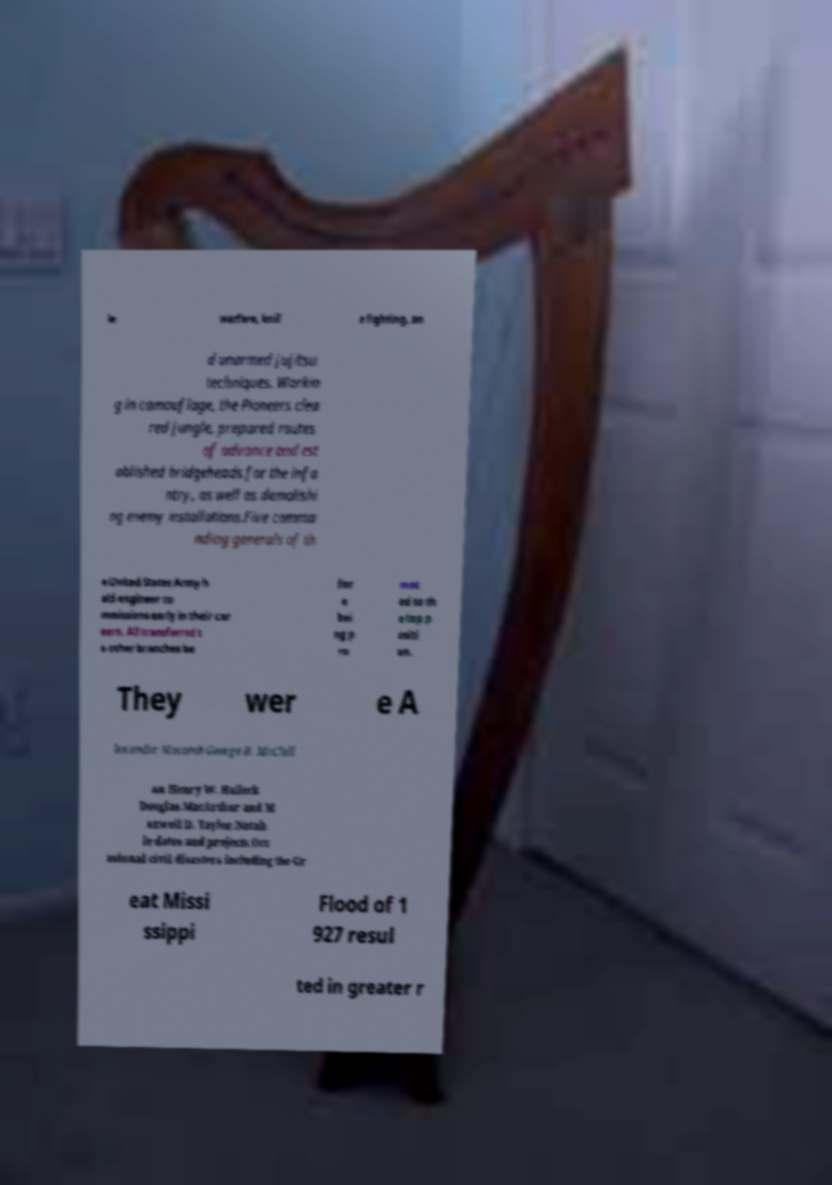Please read and relay the text visible in this image. What does it say? le warfare, knif e fighting, an d unarmed jujitsu techniques. Workin g in camouflage, the Pioneers clea red jungle, prepared routes of advance and est ablished bridgeheads for the infa ntry, as well as demolishi ng enemy installations.Five comma nding generals of th e United States Army h eld engineer co mmissions early in their car eers. All transferred t o other branches be for e bei ng p ro mot ed to th e top p ositi on. They wer e A lexander Macomb George B. McClell an Henry W. Halleck Douglas MacArthur and M axwell D. Taylor.Notab le dates and projects.Occ asional civil disasters including the Gr eat Missi ssippi Flood of 1 927 resul ted in greater r 